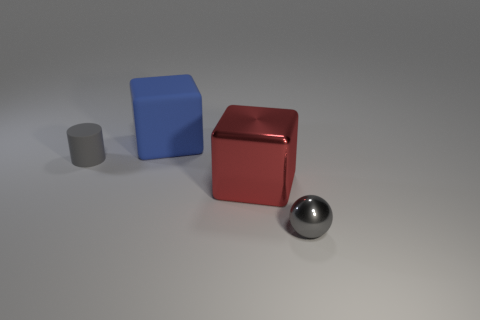There is a large shiny cube; are there any gray spheres behind it?
Keep it short and to the point. No. There is a tiny object that is the same color as the tiny ball; what is it made of?
Provide a short and direct response. Rubber. What number of cylinders are either gray metallic things or large matte things?
Your answer should be very brief. 0. Is the tiny metallic object the same shape as the red thing?
Ensure brevity in your answer.  No. There is a gray thing on the left side of the gray metal thing; how big is it?
Your answer should be very brief. Small. Are there any small shiny spheres that have the same color as the large metal block?
Your answer should be very brief. No. There is a rubber object that is behind the cylinder; is it the same size as the small matte thing?
Your response must be concise. No. What is the color of the big metallic cube?
Give a very brief answer. Red. What is the color of the tiny thing in front of the big thing that is right of the blue thing?
Your answer should be compact. Gray. Is there a big green cylinder made of the same material as the big blue object?
Give a very brief answer. No. 